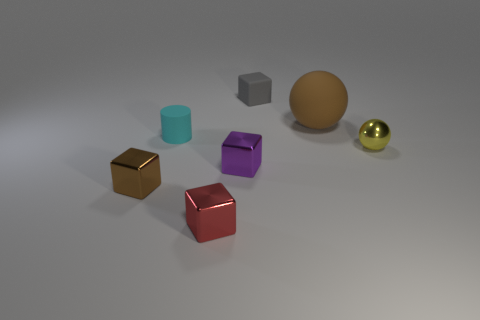Add 2 large yellow balls. How many objects exist? 9 Subtract all green blocks. Subtract all purple cylinders. How many blocks are left? 4 Subtract all spheres. How many objects are left? 5 Add 1 small purple metallic cubes. How many small purple metallic cubes are left? 2 Add 4 tiny blue spheres. How many tiny blue spheres exist? 4 Subtract 0 yellow cylinders. How many objects are left? 7 Subtract all large gray metal cubes. Subtract all tiny cylinders. How many objects are left? 6 